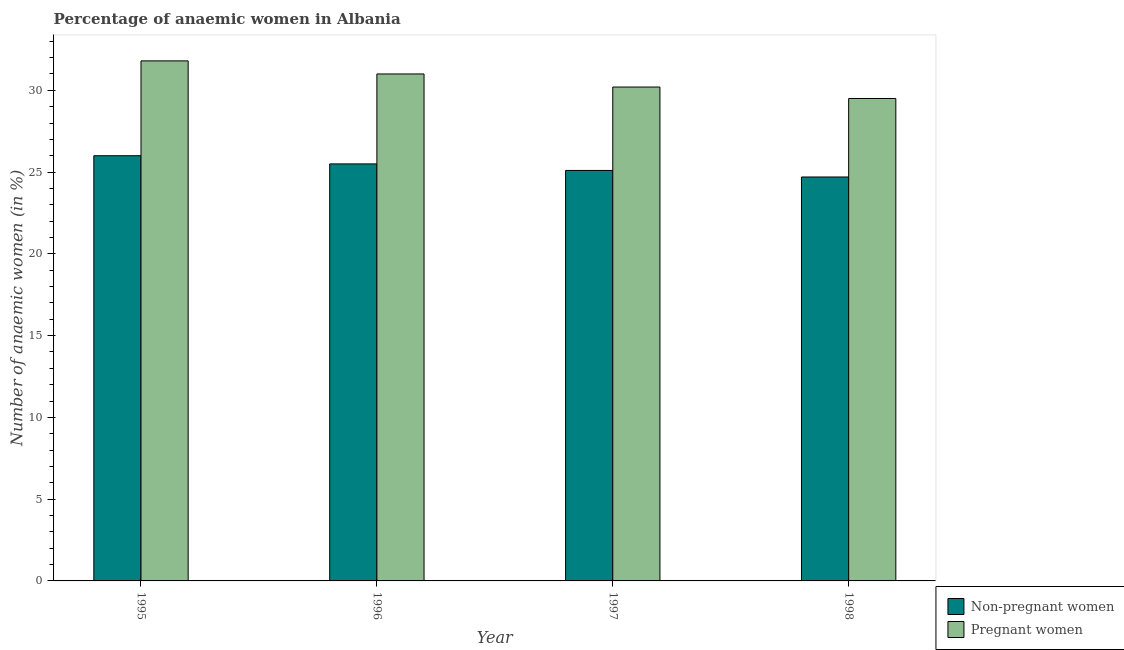How many groups of bars are there?
Your answer should be compact. 4. Are the number of bars per tick equal to the number of legend labels?
Provide a short and direct response. Yes. Are the number of bars on each tick of the X-axis equal?
Offer a terse response. Yes. How many bars are there on the 3rd tick from the right?
Keep it short and to the point. 2. What is the label of the 2nd group of bars from the left?
Provide a short and direct response. 1996. In how many cases, is the number of bars for a given year not equal to the number of legend labels?
Offer a terse response. 0. What is the percentage of non-pregnant anaemic women in 1998?
Keep it short and to the point. 24.7. Across all years, what is the maximum percentage of pregnant anaemic women?
Provide a short and direct response. 31.8. Across all years, what is the minimum percentage of pregnant anaemic women?
Offer a very short reply. 29.5. What is the total percentage of non-pregnant anaemic women in the graph?
Your answer should be compact. 101.3. What is the difference between the percentage of non-pregnant anaemic women in 1995 and that in 1997?
Provide a succinct answer. 0.9. What is the average percentage of non-pregnant anaemic women per year?
Offer a very short reply. 25.32. In the year 1996, what is the difference between the percentage of pregnant anaemic women and percentage of non-pregnant anaemic women?
Provide a succinct answer. 0. What is the ratio of the percentage of non-pregnant anaemic women in 1997 to that in 1998?
Offer a terse response. 1.02. What is the difference between the highest and the second highest percentage of non-pregnant anaemic women?
Your answer should be compact. 0.5. What is the difference between the highest and the lowest percentage of non-pregnant anaemic women?
Provide a succinct answer. 1.3. In how many years, is the percentage of pregnant anaemic women greater than the average percentage of pregnant anaemic women taken over all years?
Offer a very short reply. 2. What does the 2nd bar from the left in 1996 represents?
Ensure brevity in your answer.  Pregnant women. What does the 1st bar from the right in 1997 represents?
Make the answer very short. Pregnant women. Are all the bars in the graph horizontal?
Make the answer very short. No. Are the values on the major ticks of Y-axis written in scientific E-notation?
Your answer should be compact. No. Where does the legend appear in the graph?
Provide a short and direct response. Bottom right. How many legend labels are there?
Keep it short and to the point. 2. How are the legend labels stacked?
Make the answer very short. Vertical. What is the title of the graph?
Make the answer very short. Percentage of anaemic women in Albania. What is the label or title of the X-axis?
Provide a succinct answer. Year. What is the label or title of the Y-axis?
Keep it short and to the point. Number of anaemic women (in %). What is the Number of anaemic women (in %) in Pregnant women in 1995?
Keep it short and to the point. 31.8. What is the Number of anaemic women (in %) in Non-pregnant women in 1996?
Keep it short and to the point. 25.5. What is the Number of anaemic women (in %) of Pregnant women in 1996?
Your answer should be compact. 31. What is the Number of anaemic women (in %) in Non-pregnant women in 1997?
Ensure brevity in your answer.  25.1. What is the Number of anaemic women (in %) in Pregnant women in 1997?
Make the answer very short. 30.2. What is the Number of anaemic women (in %) in Non-pregnant women in 1998?
Provide a succinct answer. 24.7. What is the Number of anaemic women (in %) of Pregnant women in 1998?
Provide a short and direct response. 29.5. Across all years, what is the maximum Number of anaemic women (in %) of Pregnant women?
Make the answer very short. 31.8. Across all years, what is the minimum Number of anaemic women (in %) of Non-pregnant women?
Keep it short and to the point. 24.7. Across all years, what is the minimum Number of anaemic women (in %) of Pregnant women?
Your answer should be compact. 29.5. What is the total Number of anaemic women (in %) of Non-pregnant women in the graph?
Offer a terse response. 101.3. What is the total Number of anaemic women (in %) in Pregnant women in the graph?
Your response must be concise. 122.5. What is the difference between the Number of anaemic women (in %) in Non-pregnant women in 1995 and that in 1996?
Offer a terse response. 0.5. What is the difference between the Number of anaemic women (in %) in Pregnant women in 1995 and that in 1996?
Give a very brief answer. 0.8. What is the difference between the Number of anaemic women (in %) of Non-pregnant women in 1995 and that in 1998?
Your response must be concise. 1.3. What is the difference between the Number of anaemic women (in %) in Non-pregnant women in 1996 and that in 1997?
Your answer should be very brief. 0.4. What is the difference between the Number of anaemic women (in %) of Pregnant women in 1996 and that in 1997?
Offer a terse response. 0.8. What is the difference between the Number of anaemic women (in %) in Non-pregnant women in 1996 and that in 1998?
Your answer should be compact. 0.8. What is the difference between the Number of anaemic women (in %) in Non-pregnant women in 1997 and that in 1998?
Your response must be concise. 0.4. What is the difference between the Number of anaemic women (in %) in Non-pregnant women in 1995 and the Number of anaemic women (in %) in Pregnant women in 1996?
Offer a very short reply. -5. What is the difference between the Number of anaemic women (in %) of Non-pregnant women in 1995 and the Number of anaemic women (in %) of Pregnant women in 1997?
Provide a short and direct response. -4.2. What is the average Number of anaemic women (in %) in Non-pregnant women per year?
Keep it short and to the point. 25.32. What is the average Number of anaemic women (in %) in Pregnant women per year?
Provide a short and direct response. 30.62. What is the ratio of the Number of anaemic women (in %) in Non-pregnant women in 1995 to that in 1996?
Your answer should be very brief. 1.02. What is the ratio of the Number of anaemic women (in %) of Pregnant women in 1995 to that in 1996?
Provide a short and direct response. 1.03. What is the ratio of the Number of anaemic women (in %) of Non-pregnant women in 1995 to that in 1997?
Keep it short and to the point. 1.04. What is the ratio of the Number of anaemic women (in %) in Pregnant women in 1995 to that in 1997?
Provide a succinct answer. 1.05. What is the ratio of the Number of anaemic women (in %) of Non-pregnant women in 1995 to that in 1998?
Make the answer very short. 1.05. What is the ratio of the Number of anaemic women (in %) of Pregnant women in 1995 to that in 1998?
Keep it short and to the point. 1.08. What is the ratio of the Number of anaemic women (in %) in Non-pregnant women in 1996 to that in 1997?
Keep it short and to the point. 1.02. What is the ratio of the Number of anaemic women (in %) of Pregnant women in 1996 to that in 1997?
Provide a short and direct response. 1.03. What is the ratio of the Number of anaemic women (in %) in Non-pregnant women in 1996 to that in 1998?
Make the answer very short. 1.03. What is the ratio of the Number of anaemic women (in %) of Pregnant women in 1996 to that in 1998?
Offer a terse response. 1.05. What is the ratio of the Number of anaemic women (in %) in Non-pregnant women in 1997 to that in 1998?
Your response must be concise. 1.02. What is the ratio of the Number of anaemic women (in %) in Pregnant women in 1997 to that in 1998?
Your answer should be very brief. 1.02. What is the difference between the highest and the second highest Number of anaemic women (in %) of Non-pregnant women?
Your answer should be very brief. 0.5. What is the difference between the highest and the lowest Number of anaemic women (in %) in Pregnant women?
Give a very brief answer. 2.3. 